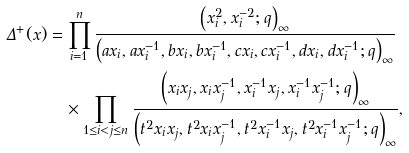Convert formula to latex. <formula><loc_0><loc_0><loc_500><loc_500>\Delta ^ { + } ( x ) & = \prod _ { i = 1 } ^ { n } \frac { \left ( x _ { i } ^ { 2 } , x _ { i } ^ { - 2 } ; q \right ) _ { \infty } } { \left ( a x _ { i } , a x _ { i } ^ { - 1 } , b x _ { i } , b x _ { i } ^ { - 1 } , c x _ { i } , c x _ { i } ^ { - 1 } , d x _ { i } , d x _ { i } ^ { - 1 } ; q \right ) _ { \infty } } \\ & \quad \times \prod _ { 1 \leq i < j \leq n } \frac { \left ( x _ { i } x _ { j } , x _ { i } x _ { j } ^ { - 1 } , x _ { i } ^ { - 1 } x _ { j } , x _ { i } ^ { - 1 } x _ { j } ^ { - 1 } ; q \right ) _ { \infty } } { \left ( t ^ { 2 } x _ { i } x _ { j } , t ^ { 2 } x _ { i } x _ { j } ^ { - 1 } , t ^ { 2 } x _ { i } ^ { - 1 } x _ { j } , t ^ { 2 } x _ { i } ^ { - 1 } x _ { j } ^ { - 1 } ; q \right ) _ { \infty } } ,</formula> 